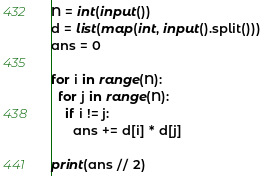Convert code to text. <code><loc_0><loc_0><loc_500><loc_500><_Python_>N = int(input())
d = list(map(int, input().split()))
ans = 0

for i in range(N):
  for j in range(N):
    if i != j:
      ans += d[i] * d[j]
  
print(ans // 2)</code> 